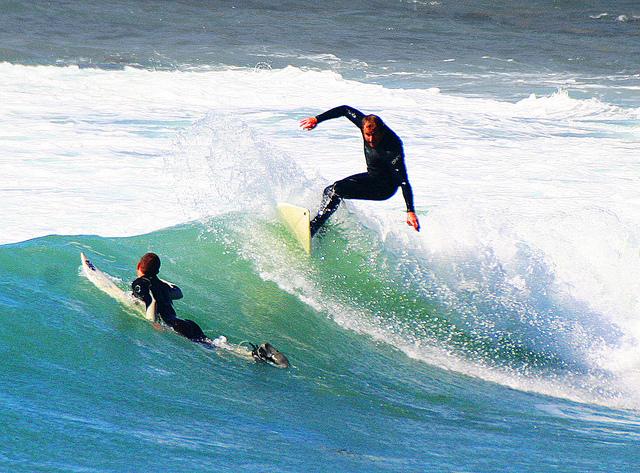Is the surfer surfing goofy foot?
Concise answer only. No. How many surfers are standing?
Concise answer only. 1. What are the surfers wearing?
Concise answer only. Wetsuits. 